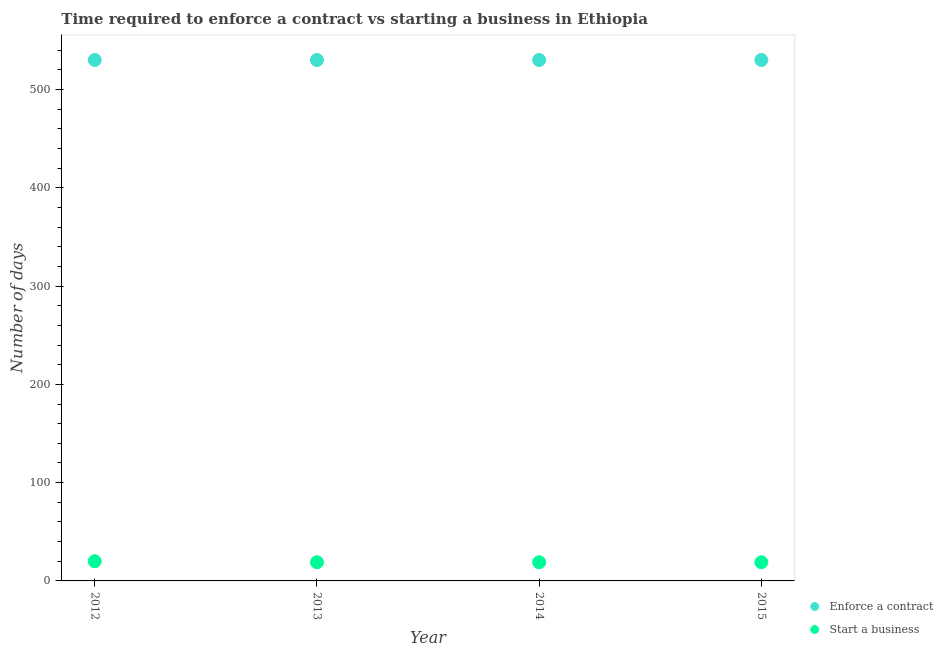How many different coloured dotlines are there?
Make the answer very short. 2. What is the number of days to start a business in 2013?
Give a very brief answer. 19. Across all years, what is the maximum number of days to enforece a contract?
Offer a very short reply. 530. Across all years, what is the minimum number of days to start a business?
Keep it short and to the point. 19. In which year was the number of days to start a business maximum?
Keep it short and to the point. 2012. What is the total number of days to enforece a contract in the graph?
Offer a terse response. 2120. What is the difference between the number of days to enforece a contract in 2012 and that in 2014?
Keep it short and to the point. 0. What is the difference between the number of days to start a business in 2014 and the number of days to enforece a contract in 2012?
Give a very brief answer. -511. What is the average number of days to start a business per year?
Make the answer very short. 19.25. In the year 2013, what is the difference between the number of days to enforece a contract and number of days to start a business?
Provide a short and direct response. 511. What is the ratio of the number of days to start a business in 2012 to that in 2013?
Offer a very short reply. 1.05. Is the number of days to enforece a contract in 2014 less than that in 2015?
Make the answer very short. No. Is the difference between the number of days to enforece a contract in 2013 and 2015 greater than the difference between the number of days to start a business in 2013 and 2015?
Make the answer very short. No. What is the difference between the highest and the second highest number of days to start a business?
Keep it short and to the point. 1. What is the difference between the highest and the lowest number of days to start a business?
Make the answer very short. 1. How many years are there in the graph?
Provide a short and direct response. 4. What is the difference between two consecutive major ticks on the Y-axis?
Provide a short and direct response. 100. Does the graph contain any zero values?
Your answer should be very brief. No. Does the graph contain grids?
Ensure brevity in your answer.  No. How many legend labels are there?
Keep it short and to the point. 2. What is the title of the graph?
Offer a terse response. Time required to enforce a contract vs starting a business in Ethiopia. What is the label or title of the X-axis?
Keep it short and to the point. Year. What is the label or title of the Y-axis?
Your answer should be compact. Number of days. What is the Number of days in Enforce a contract in 2012?
Offer a terse response. 530. What is the Number of days in Start a business in 2012?
Provide a short and direct response. 20. What is the Number of days in Enforce a contract in 2013?
Your answer should be very brief. 530. What is the Number of days of Enforce a contract in 2014?
Provide a short and direct response. 530. What is the Number of days of Start a business in 2014?
Your response must be concise. 19. What is the Number of days of Enforce a contract in 2015?
Provide a succinct answer. 530. What is the Number of days in Start a business in 2015?
Keep it short and to the point. 19. Across all years, what is the maximum Number of days in Enforce a contract?
Offer a terse response. 530. Across all years, what is the minimum Number of days in Enforce a contract?
Give a very brief answer. 530. Across all years, what is the minimum Number of days of Start a business?
Give a very brief answer. 19. What is the total Number of days of Enforce a contract in the graph?
Keep it short and to the point. 2120. What is the total Number of days in Start a business in the graph?
Offer a terse response. 77. What is the difference between the Number of days in Start a business in 2012 and that in 2014?
Your answer should be very brief. 1. What is the difference between the Number of days in Enforce a contract in 2013 and that in 2015?
Offer a terse response. 0. What is the difference between the Number of days in Enforce a contract in 2014 and that in 2015?
Provide a short and direct response. 0. What is the difference between the Number of days of Start a business in 2014 and that in 2015?
Your answer should be very brief. 0. What is the difference between the Number of days in Enforce a contract in 2012 and the Number of days in Start a business in 2013?
Provide a short and direct response. 511. What is the difference between the Number of days in Enforce a contract in 2012 and the Number of days in Start a business in 2014?
Give a very brief answer. 511. What is the difference between the Number of days in Enforce a contract in 2012 and the Number of days in Start a business in 2015?
Provide a short and direct response. 511. What is the difference between the Number of days in Enforce a contract in 2013 and the Number of days in Start a business in 2014?
Ensure brevity in your answer.  511. What is the difference between the Number of days of Enforce a contract in 2013 and the Number of days of Start a business in 2015?
Provide a succinct answer. 511. What is the difference between the Number of days of Enforce a contract in 2014 and the Number of days of Start a business in 2015?
Offer a terse response. 511. What is the average Number of days in Enforce a contract per year?
Your answer should be compact. 530. What is the average Number of days of Start a business per year?
Your answer should be compact. 19.25. In the year 2012, what is the difference between the Number of days of Enforce a contract and Number of days of Start a business?
Your answer should be very brief. 510. In the year 2013, what is the difference between the Number of days in Enforce a contract and Number of days in Start a business?
Give a very brief answer. 511. In the year 2014, what is the difference between the Number of days in Enforce a contract and Number of days in Start a business?
Make the answer very short. 511. In the year 2015, what is the difference between the Number of days of Enforce a contract and Number of days of Start a business?
Provide a short and direct response. 511. What is the ratio of the Number of days in Enforce a contract in 2012 to that in 2013?
Offer a very short reply. 1. What is the ratio of the Number of days in Start a business in 2012 to that in 2013?
Ensure brevity in your answer.  1.05. What is the ratio of the Number of days of Enforce a contract in 2012 to that in 2014?
Your answer should be compact. 1. What is the ratio of the Number of days in Start a business in 2012 to that in 2014?
Your response must be concise. 1.05. What is the ratio of the Number of days in Enforce a contract in 2012 to that in 2015?
Keep it short and to the point. 1. What is the ratio of the Number of days in Start a business in 2012 to that in 2015?
Give a very brief answer. 1.05. What is the ratio of the Number of days in Enforce a contract in 2013 to that in 2014?
Your answer should be compact. 1. What is the ratio of the Number of days of Enforce a contract in 2013 to that in 2015?
Offer a very short reply. 1. What is the ratio of the Number of days in Start a business in 2013 to that in 2015?
Provide a short and direct response. 1. What is the ratio of the Number of days in Enforce a contract in 2014 to that in 2015?
Offer a very short reply. 1. What is the ratio of the Number of days in Start a business in 2014 to that in 2015?
Provide a succinct answer. 1. What is the difference between the highest and the second highest Number of days in Start a business?
Your response must be concise. 1. What is the difference between the highest and the lowest Number of days of Start a business?
Provide a short and direct response. 1. 